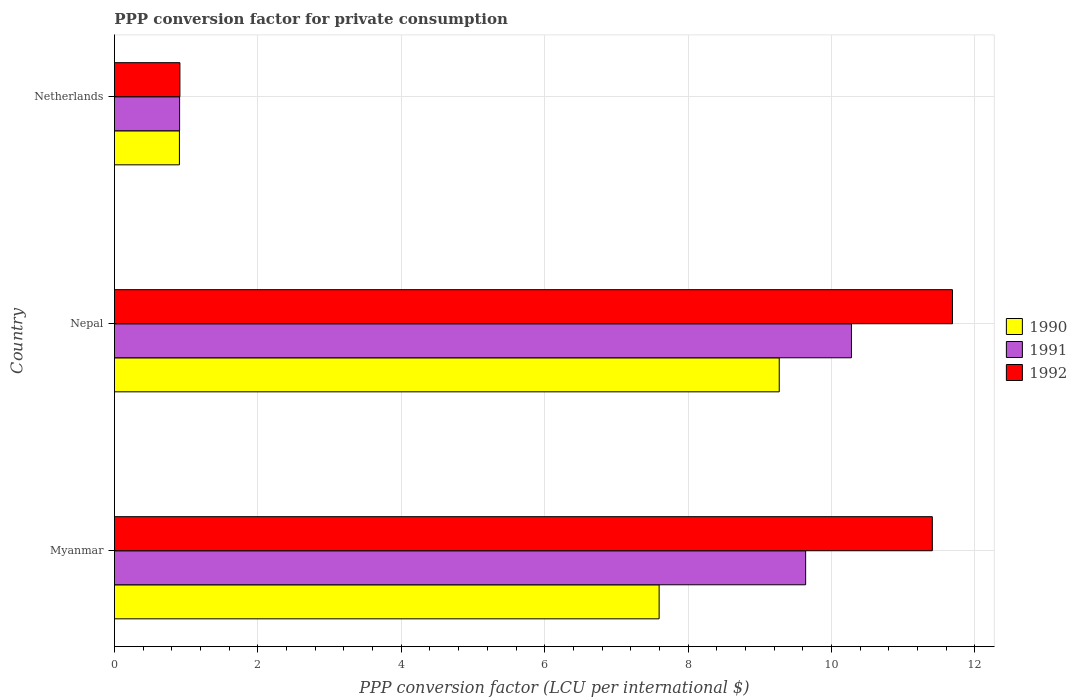How many different coloured bars are there?
Keep it short and to the point. 3. How many groups of bars are there?
Ensure brevity in your answer.  3. Are the number of bars per tick equal to the number of legend labels?
Provide a short and direct response. Yes. Are the number of bars on each tick of the Y-axis equal?
Ensure brevity in your answer.  Yes. How many bars are there on the 2nd tick from the top?
Keep it short and to the point. 3. How many bars are there on the 1st tick from the bottom?
Provide a succinct answer. 3. What is the PPP conversion factor for private consumption in 1992 in Nepal?
Your response must be concise. 11.69. Across all countries, what is the maximum PPP conversion factor for private consumption in 1990?
Give a very brief answer. 9.27. Across all countries, what is the minimum PPP conversion factor for private consumption in 1990?
Ensure brevity in your answer.  0.91. In which country was the PPP conversion factor for private consumption in 1990 maximum?
Offer a very short reply. Nepal. In which country was the PPP conversion factor for private consumption in 1990 minimum?
Offer a terse response. Netherlands. What is the total PPP conversion factor for private consumption in 1990 in the graph?
Provide a short and direct response. 17.77. What is the difference between the PPP conversion factor for private consumption in 1992 in Myanmar and that in Nepal?
Provide a succinct answer. -0.28. What is the difference between the PPP conversion factor for private consumption in 1990 in Netherlands and the PPP conversion factor for private consumption in 1991 in Myanmar?
Provide a short and direct response. -8.73. What is the average PPP conversion factor for private consumption in 1992 per country?
Your answer should be very brief. 8. What is the difference between the PPP conversion factor for private consumption in 1991 and PPP conversion factor for private consumption in 1990 in Netherlands?
Make the answer very short. 0. In how many countries, is the PPP conversion factor for private consumption in 1992 greater than 2.8 LCU?
Keep it short and to the point. 2. What is the ratio of the PPP conversion factor for private consumption in 1992 in Myanmar to that in Nepal?
Provide a short and direct response. 0.98. Is the PPP conversion factor for private consumption in 1991 in Nepal less than that in Netherlands?
Offer a terse response. No. Is the difference between the PPP conversion factor for private consumption in 1991 in Myanmar and Nepal greater than the difference between the PPP conversion factor for private consumption in 1990 in Myanmar and Nepal?
Give a very brief answer. Yes. What is the difference between the highest and the second highest PPP conversion factor for private consumption in 1990?
Give a very brief answer. 1.67. What is the difference between the highest and the lowest PPP conversion factor for private consumption in 1991?
Offer a very short reply. 9.37. In how many countries, is the PPP conversion factor for private consumption in 1992 greater than the average PPP conversion factor for private consumption in 1992 taken over all countries?
Offer a very short reply. 2. What does the 1st bar from the top in Nepal represents?
Give a very brief answer. 1992. What does the 2nd bar from the bottom in Myanmar represents?
Make the answer very short. 1991. Does the graph contain grids?
Your answer should be very brief. Yes. Where does the legend appear in the graph?
Provide a short and direct response. Center right. What is the title of the graph?
Provide a succinct answer. PPP conversion factor for private consumption. Does "1964" appear as one of the legend labels in the graph?
Your answer should be compact. No. What is the label or title of the X-axis?
Provide a succinct answer. PPP conversion factor (LCU per international $). What is the label or title of the Y-axis?
Keep it short and to the point. Country. What is the PPP conversion factor (LCU per international $) in 1990 in Myanmar?
Your answer should be compact. 7.6. What is the PPP conversion factor (LCU per international $) of 1991 in Myanmar?
Provide a succinct answer. 9.64. What is the PPP conversion factor (LCU per international $) in 1992 in Myanmar?
Your response must be concise. 11.41. What is the PPP conversion factor (LCU per international $) in 1990 in Nepal?
Your response must be concise. 9.27. What is the PPP conversion factor (LCU per international $) of 1991 in Nepal?
Keep it short and to the point. 10.28. What is the PPP conversion factor (LCU per international $) of 1992 in Nepal?
Provide a short and direct response. 11.69. What is the PPP conversion factor (LCU per international $) of 1990 in Netherlands?
Your answer should be very brief. 0.91. What is the PPP conversion factor (LCU per international $) of 1991 in Netherlands?
Provide a succinct answer. 0.91. What is the PPP conversion factor (LCU per international $) in 1992 in Netherlands?
Ensure brevity in your answer.  0.91. Across all countries, what is the maximum PPP conversion factor (LCU per international $) of 1990?
Give a very brief answer. 9.27. Across all countries, what is the maximum PPP conversion factor (LCU per international $) in 1991?
Keep it short and to the point. 10.28. Across all countries, what is the maximum PPP conversion factor (LCU per international $) of 1992?
Keep it short and to the point. 11.69. Across all countries, what is the minimum PPP conversion factor (LCU per international $) of 1990?
Your answer should be very brief. 0.91. Across all countries, what is the minimum PPP conversion factor (LCU per international $) of 1991?
Your response must be concise. 0.91. Across all countries, what is the minimum PPP conversion factor (LCU per international $) of 1992?
Your answer should be very brief. 0.91. What is the total PPP conversion factor (LCU per international $) in 1990 in the graph?
Offer a very short reply. 17.77. What is the total PPP conversion factor (LCU per international $) of 1991 in the graph?
Provide a succinct answer. 20.82. What is the total PPP conversion factor (LCU per international $) in 1992 in the graph?
Offer a terse response. 24. What is the difference between the PPP conversion factor (LCU per international $) in 1990 in Myanmar and that in Nepal?
Your response must be concise. -1.67. What is the difference between the PPP conversion factor (LCU per international $) of 1991 in Myanmar and that in Nepal?
Provide a short and direct response. -0.64. What is the difference between the PPP conversion factor (LCU per international $) in 1992 in Myanmar and that in Nepal?
Your answer should be very brief. -0.28. What is the difference between the PPP conversion factor (LCU per international $) of 1990 in Myanmar and that in Netherlands?
Your answer should be compact. 6.69. What is the difference between the PPP conversion factor (LCU per international $) in 1991 in Myanmar and that in Netherlands?
Offer a terse response. 8.73. What is the difference between the PPP conversion factor (LCU per international $) in 1992 in Myanmar and that in Netherlands?
Offer a very short reply. 10.49. What is the difference between the PPP conversion factor (LCU per international $) in 1990 in Nepal and that in Netherlands?
Provide a short and direct response. 8.36. What is the difference between the PPP conversion factor (LCU per international $) of 1991 in Nepal and that in Netherlands?
Provide a short and direct response. 9.37. What is the difference between the PPP conversion factor (LCU per international $) in 1992 in Nepal and that in Netherlands?
Offer a very short reply. 10.77. What is the difference between the PPP conversion factor (LCU per international $) in 1990 in Myanmar and the PPP conversion factor (LCU per international $) in 1991 in Nepal?
Give a very brief answer. -2.68. What is the difference between the PPP conversion factor (LCU per international $) of 1990 in Myanmar and the PPP conversion factor (LCU per international $) of 1992 in Nepal?
Your answer should be very brief. -4.09. What is the difference between the PPP conversion factor (LCU per international $) in 1991 in Myanmar and the PPP conversion factor (LCU per international $) in 1992 in Nepal?
Offer a terse response. -2.05. What is the difference between the PPP conversion factor (LCU per international $) in 1990 in Myanmar and the PPP conversion factor (LCU per international $) in 1991 in Netherlands?
Give a very brief answer. 6.69. What is the difference between the PPP conversion factor (LCU per international $) of 1990 in Myanmar and the PPP conversion factor (LCU per international $) of 1992 in Netherlands?
Ensure brevity in your answer.  6.68. What is the difference between the PPP conversion factor (LCU per international $) in 1991 in Myanmar and the PPP conversion factor (LCU per international $) in 1992 in Netherlands?
Your answer should be compact. 8.73. What is the difference between the PPP conversion factor (LCU per international $) in 1990 in Nepal and the PPP conversion factor (LCU per international $) in 1991 in Netherlands?
Your answer should be compact. 8.36. What is the difference between the PPP conversion factor (LCU per international $) of 1990 in Nepal and the PPP conversion factor (LCU per international $) of 1992 in Netherlands?
Your answer should be compact. 8.36. What is the difference between the PPP conversion factor (LCU per international $) of 1991 in Nepal and the PPP conversion factor (LCU per international $) of 1992 in Netherlands?
Ensure brevity in your answer.  9.36. What is the average PPP conversion factor (LCU per international $) of 1990 per country?
Provide a succinct answer. 5.92. What is the average PPP conversion factor (LCU per international $) of 1991 per country?
Your answer should be compact. 6.94. What is the average PPP conversion factor (LCU per international $) in 1992 per country?
Make the answer very short. 8. What is the difference between the PPP conversion factor (LCU per international $) of 1990 and PPP conversion factor (LCU per international $) of 1991 in Myanmar?
Ensure brevity in your answer.  -2.04. What is the difference between the PPP conversion factor (LCU per international $) of 1990 and PPP conversion factor (LCU per international $) of 1992 in Myanmar?
Offer a very short reply. -3.81. What is the difference between the PPP conversion factor (LCU per international $) in 1991 and PPP conversion factor (LCU per international $) in 1992 in Myanmar?
Your response must be concise. -1.77. What is the difference between the PPP conversion factor (LCU per international $) in 1990 and PPP conversion factor (LCU per international $) in 1991 in Nepal?
Provide a short and direct response. -1.01. What is the difference between the PPP conversion factor (LCU per international $) of 1990 and PPP conversion factor (LCU per international $) of 1992 in Nepal?
Provide a succinct answer. -2.42. What is the difference between the PPP conversion factor (LCU per international $) in 1991 and PPP conversion factor (LCU per international $) in 1992 in Nepal?
Your response must be concise. -1.41. What is the difference between the PPP conversion factor (LCU per international $) of 1990 and PPP conversion factor (LCU per international $) of 1991 in Netherlands?
Your answer should be very brief. -0. What is the difference between the PPP conversion factor (LCU per international $) of 1990 and PPP conversion factor (LCU per international $) of 1992 in Netherlands?
Offer a very short reply. -0.01. What is the difference between the PPP conversion factor (LCU per international $) of 1991 and PPP conversion factor (LCU per international $) of 1992 in Netherlands?
Your answer should be compact. -0. What is the ratio of the PPP conversion factor (LCU per international $) of 1990 in Myanmar to that in Nepal?
Your answer should be very brief. 0.82. What is the ratio of the PPP conversion factor (LCU per international $) in 1991 in Myanmar to that in Nepal?
Your answer should be very brief. 0.94. What is the ratio of the PPP conversion factor (LCU per international $) of 1990 in Myanmar to that in Netherlands?
Your response must be concise. 8.38. What is the ratio of the PPP conversion factor (LCU per international $) in 1991 in Myanmar to that in Netherlands?
Provide a short and direct response. 10.6. What is the ratio of the PPP conversion factor (LCU per international $) in 1992 in Myanmar to that in Netherlands?
Keep it short and to the point. 12.49. What is the ratio of the PPP conversion factor (LCU per international $) of 1990 in Nepal to that in Netherlands?
Give a very brief answer. 10.23. What is the ratio of the PPP conversion factor (LCU per international $) of 1991 in Nepal to that in Netherlands?
Ensure brevity in your answer.  11.31. What is the ratio of the PPP conversion factor (LCU per international $) of 1992 in Nepal to that in Netherlands?
Give a very brief answer. 12.8. What is the difference between the highest and the second highest PPP conversion factor (LCU per international $) of 1990?
Ensure brevity in your answer.  1.67. What is the difference between the highest and the second highest PPP conversion factor (LCU per international $) of 1991?
Make the answer very short. 0.64. What is the difference between the highest and the second highest PPP conversion factor (LCU per international $) of 1992?
Provide a short and direct response. 0.28. What is the difference between the highest and the lowest PPP conversion factor (LCU per international $) of 1990?
Provide a short and direct response. 8.36. What is the difference between the highest and the lowest PPP conversion factor (LCU per international $) in 1991?
Make the answer very short. 9.37. What is the difference between the highest and the lowest PPP conversion factor (LCU per international $) of 1992?
Your answer should be compact. 10.77. 